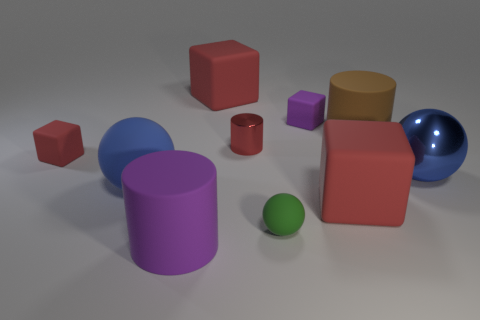Subtract all red cubes. How many were subtracted if there are1red cubes left? 2 Subtract all purple cylinders. How many red cubes are left? 3 Subtract all spheres. How many objects are left? 7 Add 6 purple blocks. How many purple blocks are left? 7 Add 5 tiny yellow rubber cylinders. How many tiny yellow rubber cylinders exist? 5 Subtract 1 red cylinders. How many objects are left? 9 Subtract all blue matte objects. Subtract all big red rubber blocks. How many objects are left? 7 